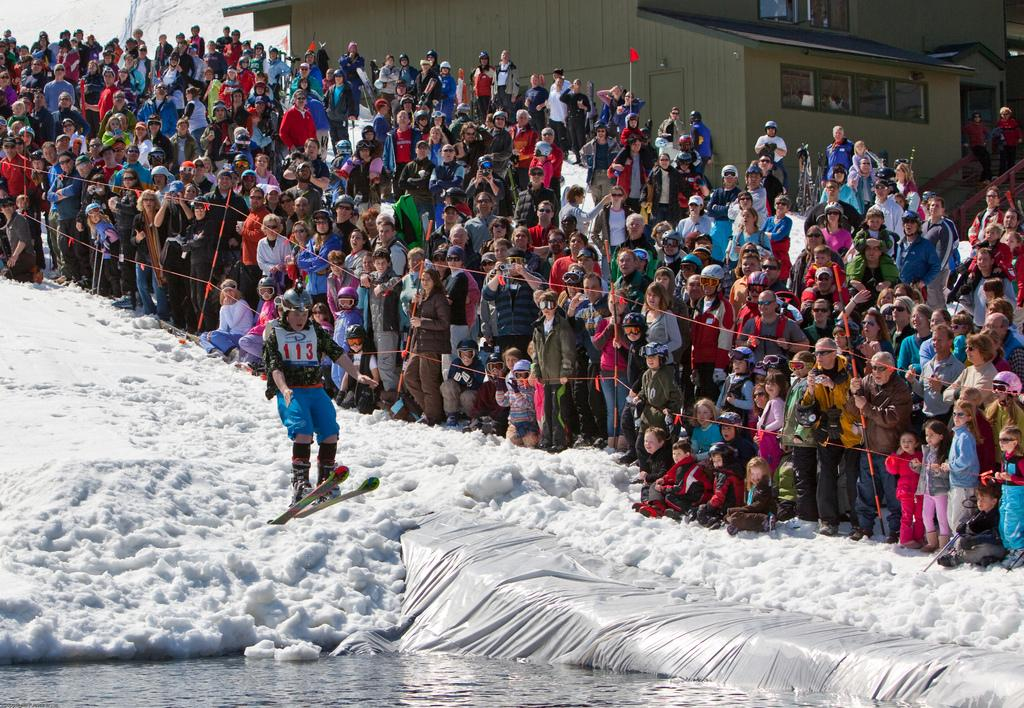What are the people in the image doing? Some people are standing, and others are sitting in the image. What can be seen in the background of the image? Buildings are visible in the background of the image. What activity is being performed by a human in the image? A human is skiing on the snow in the image. What type of bean is being dropped by the person in the image? There is no person dropping a bean in the image. What is the aftermath of the event in the image? There is no specific event mentioned in the image, so it's not possible to describe an aftermath. 